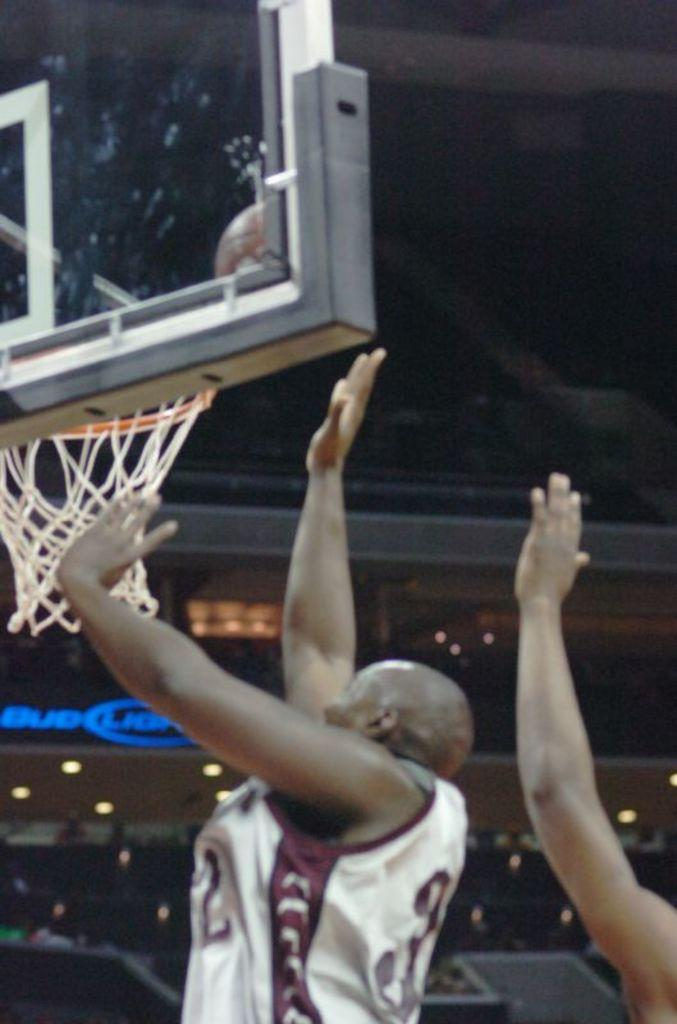Who or what is present in the image? There are people in the image. What activity might be taking place in the image? The presence of a basketball goal post suggests that the people might be playing basketball. What can be seen illuminating the scene in the image? There are lights visible in the image. What can be seen in the distance in the image? There are objects in the background of the image. What type of powder is being used to destroy the flag in the image? There is no flag or powder present in the image, and therefore no such activity can be observed. 